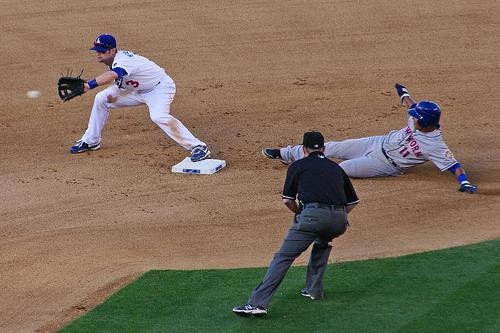Question: who is on the floor?
Choices:
A. The man.
B. Woman.
C. Friend.
D. Dog.
Answer with the letter. Answer: A Question: what sport is being played?
Choices:
A. Basketball.
B. Volleyball.
C. Soccer.
D. Baseball.
Answer with the letter. Answer: D Question: how many people are there?
Choices:
A. Two.
B. Three.
C. One.
D. Four.
Answer with the letter. Answer: B Question: where was the photo taken?
Choices:
A. On city street.
B. At a baseball field.
C. Top of the Eiffel Tower.
D. In a castle.
Answer with the letter. Answer: B Question: why is it so bright?
Choices:
A. Window open.
B. Glare.
C. Blinds open.
D. Sunny.
Answer with the letter. Answer: D Question: what is the man in the black hat doing?
Choices:
A. Leaning over.
B. Running.
C. Walking.
D. Talking.
Answer with the letter. Answer: A 